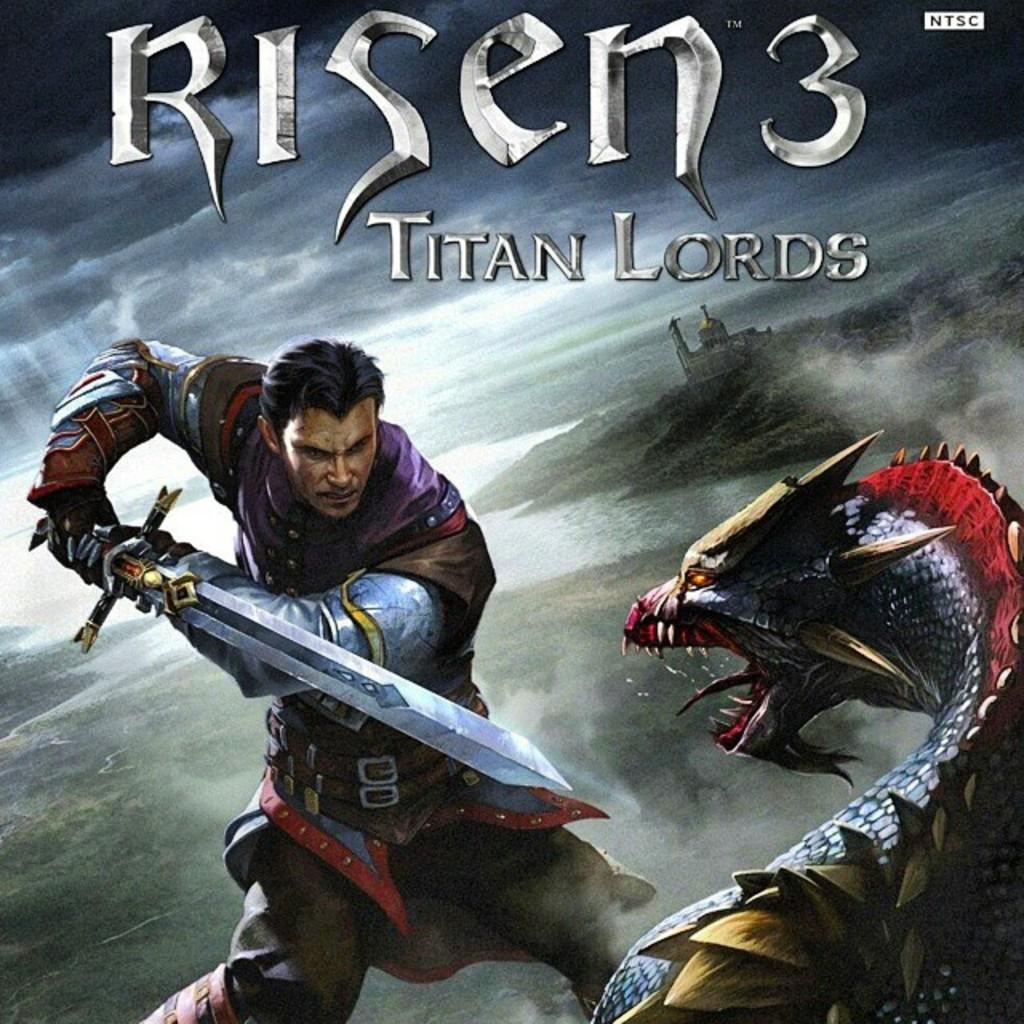What is the main subject of the poster in the image? The poster features a person holding a sword. Are there any other elements on the poster besides the person with the sword? Yes, there is an animal and a house depicted on the poster. Is there any text on the poster? Yes, there is text on the poster. How does the poster react to an earthquake in the image? There is no earthquake present in the image, and therefore the poster does not react to one. What part of the person's body is holding the sword in the image? The person's hand is holding the sword in the image. 